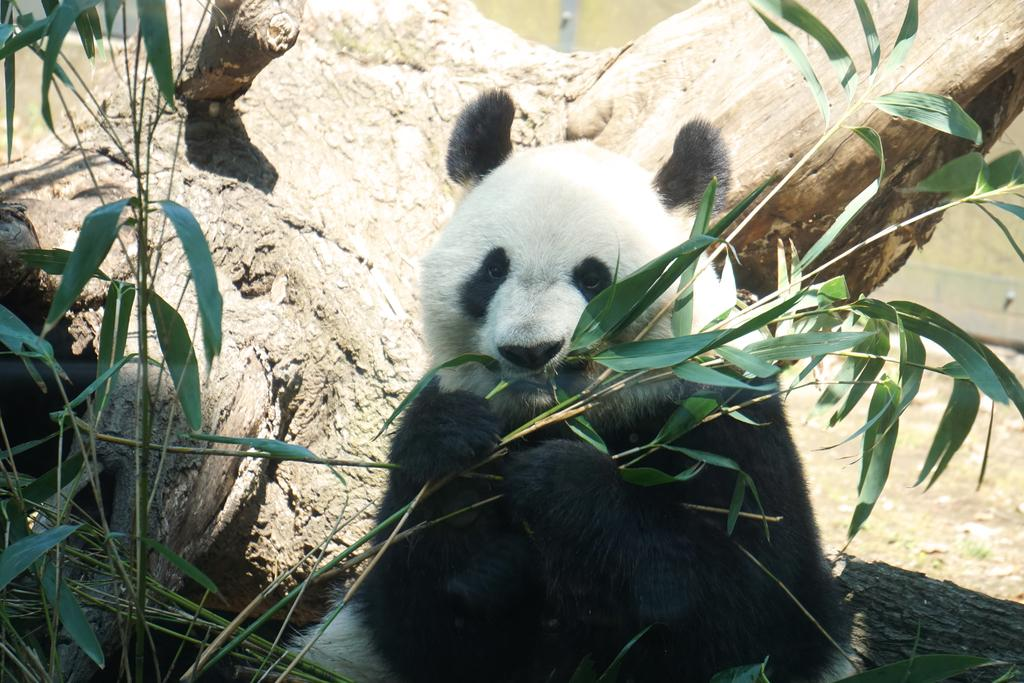What animal is featured in the image? There is a panda in the image. What is the panda doing in the image? The panda is sitting on a tree. What type of vegetation can be seen near the tree in the image? There are plants with long leaves near the tree in the image. How many fish are swimming in the snow near the panda in the image? There are no fish or snow present in the image; it features a panda sitting on a tree with plants nearby. 